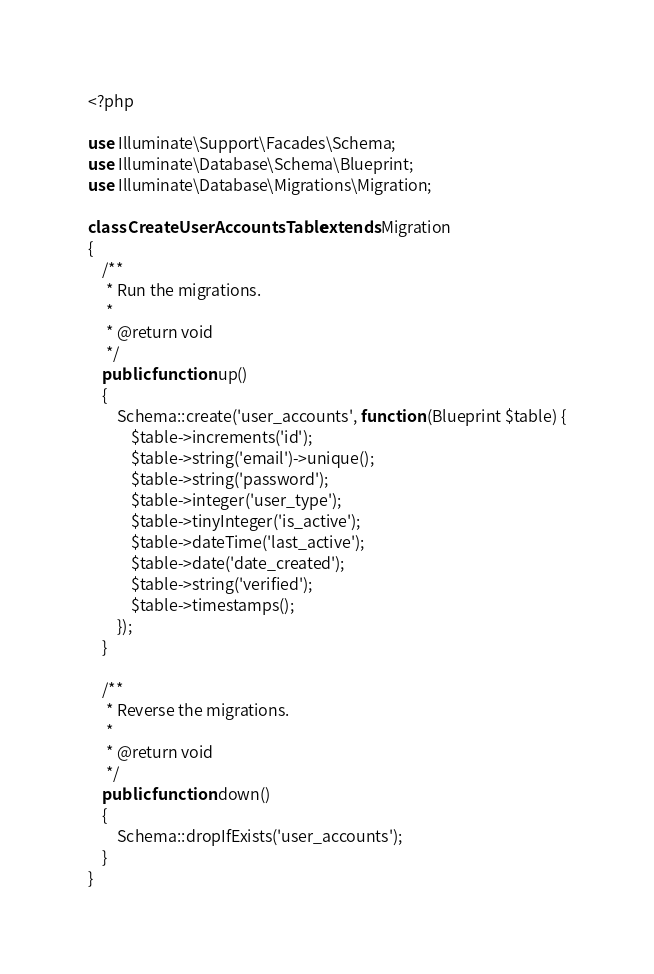<code> <loc_0><loc_0><loc_500><loc_500><_PHP_><?php

use Illuminate\Support\Facades\Schema;
use Illuminate\Database\Schema\Blueprint;
use Illuminate\Database\Migrations\Migration;

class CreateUserAccountsTable extends Migration
{
    /**
     * Run the migrations.
     *
     * @return void
     */
    public function up()
    {
        Schema::create('user_accounts', function (Blueprint $table) {
            $table->increments('id');
            $table->string('email')->unique();
            $table->string('password');
            $table->integer('user_type');
            $table->tinyInteger('is_active');
            $table->dateTime('last_active');
            $table->date('date_created');
            $table->string('verified');
            $table->timestamps();
        });
    }

    /**
     * Reverse the migrations.
     *
     * @return void
     */
    public function down()
    {
        Schema::dropIfExists('user_accounts');
    }
}
</code> 